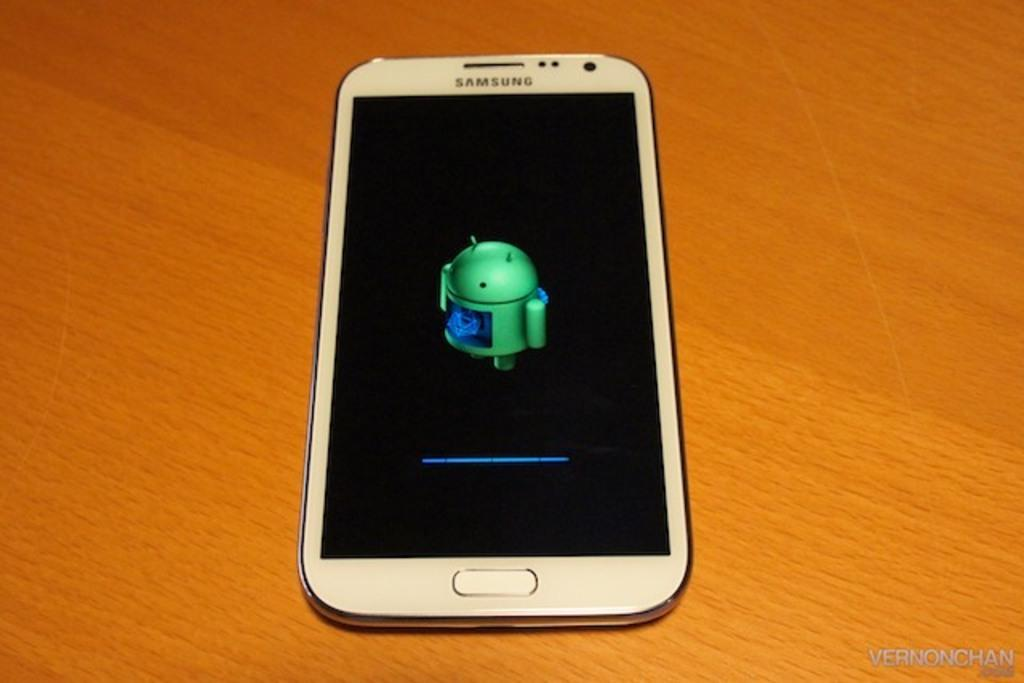<image>
Write a terse but informative summary of the picture. White Samsung phone with a black screen that has a progress bar. 